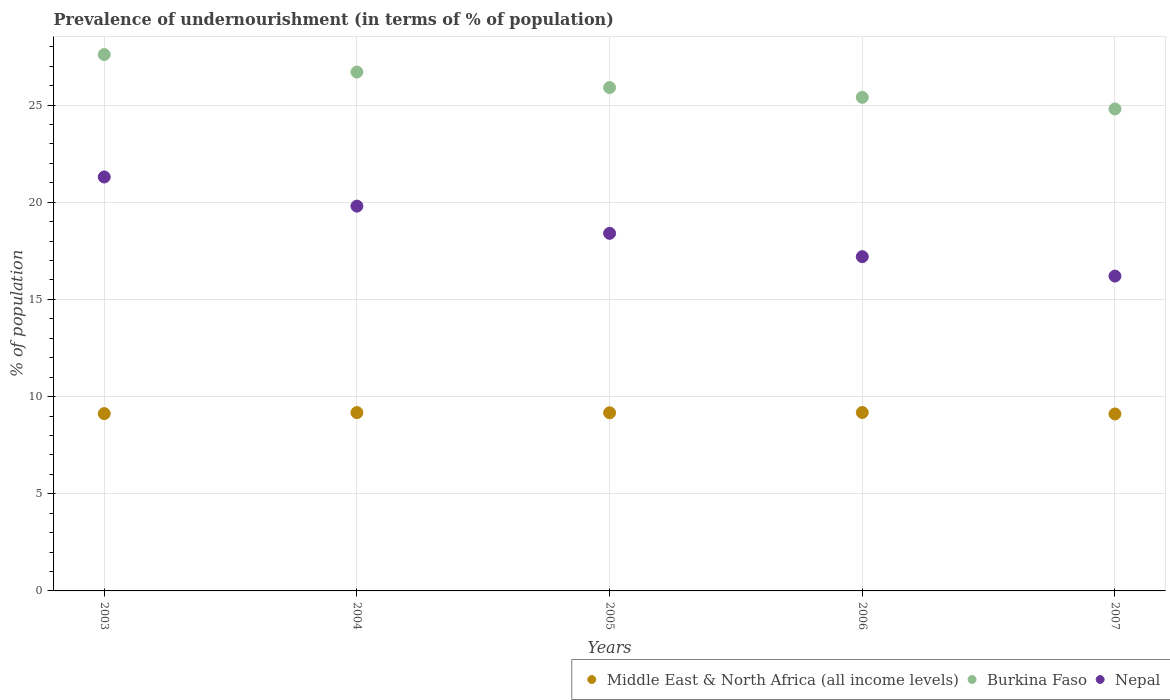How many different coloured dotlines are there?
Give a very brief answer. 3. Is the number of dotlines equal to the number of legend labels?
Your response must be concise. Yes. What is the percentage of undernourished population in Burkina Faso in 2003?
Provide a succinct answer. 27.6. Across all years, what is the maximum percentage of undernourished population in Nepal?
Give a very brief answer. 21.3. Across all years, what is the minimum percentage of undernourished population in Burkina Faso?
Provide a succinct answer. 24.8. What is the total percentage of undernourished population in Nepal in the graph?
Provide a short and direct response. 92.9. What is the difference between the percentage of undernourished population in Burkina Faso in 2003 and that in 2007?
Give a very brief answer. 2.8. What is the difference between the percentage of undernourished population in Middle East & North Africa (all income levels) in 2003 and the percentage of undernourished population in Nepal in 2007?
Keep it short and to the point. -7.08. What is the average percentage of undernourished population in Burkina Faso per year?
Provide a succinct answer. 26.08. In the year 2003, what is the difference between the percentage of undernourished population in Middle East & North Africa (all income levels) and percentage of undernourished population in Burkina Faso?
Make the answer very short. -18.48. What is the ratio of the percentage of undernourished population in Burkina Faso in 2004 to that in 2005?
Offer a terse response. 1.03. Is the difference between the percentage of undernourished population in Middle East & North Africa (all income levels) in 2003 and 2004 greater than the difference between the percentage of undernourished population in Burkina Faso in 2003 and 2004?
Make the answer very short. No. What is the difference between the highest and the second highest percentage of undernourished population in Burkina Faso?
Offer a very short reply. 0.9. What is the difference between the highest and the lowest percentage of undernourished population in Burkina Faso?
Make the answer very short. 2.8. In how many years, is the percentage of undernourished population in Burkina Faso greater than the average percentage of undernourished population in Burkina Faso taken over all years?
Ensure brevity in your answer.  2. Is the sum of the percentage of undernourished population in Middle East & North Africa (all income levels) in 2003 and 2004 greater than the maximum percentage of undernourished population in Burkina Faso across all years?
Offer a terse response. No. How many dotlines are there?
Keep it short and to the point. 3. What is the difference between two consecutive major ticks on the Y-axis?
Provide a short and direct response. 5. Are the values on the major ticks of Y-axis written in scientific E-notation?
Your answer should be very brief. No. How many legend labels are there?
Give a very brief answer. 3. How are the legend labels stacked?
Offer a terse response. Horizontal. What is the title of the graph?
Your answer should be compact. Prevalence of undernourishment (in terms of % of population). What is the label or title of the X-axis?
Provide a short and direct response. Years. What is the label or title of the Y-axis?
Keep it short and to the point. % of population. What is the % of population of Middle East & North Africa (all income levels) in 2003?
Offer a very short reply. 9.12. What is the % of population of Burkina Faso in 2003?
Ensure brevity in your answer.  27.6. What is the % of population in Nepal in 2003?
Give a very brief answer. 21.3. What is the % of population of Middle East & North Africa (all income levels) in 2004?
Offer a terse response. 9.18. What is the % of population in Burkina Faso in 2004?
Keep it short and to the point. 26.7. What is the % of population of Nepal in 2004?
Your response must be concise. 19.8. What is the % of population in Middle East & North Africa (all income levels) in 2005?
Give a very brief answer. 9.17. What is the % of population of Burkina Faso in 2005?
Ensure brevity in your answer.  25.9. What is the % of population in Nepal in 2005?
Make the answer very short. 18.4. What is the % of population in Middle East & North Africa (all income levels) in 2006?
Ensure brevity in your answer.  9.18. What is the % of population of Burkina Faso in 2006?
Ensure brevity in your answer.  25.4. What is the % of population of Nepal in 2006?
Your response must be concise. 17.2. What is the % of population in Middle East & North Africa (all income levels) in 2007?
Ensure brevity in your answer.  9.11. What is the % of population of Burkina Faso in 2007?
Ensure brevity in your answer.  24.8. What is the % of population of Nepal in 2007?
Keep it short and to the point. 16.2. Across all years, what is the maximum % of population of Middle East & North Africa (all income levels)?
Offer a terse response. 9.18. Across all years, what is the maximum % of population in Burkina Faso?
Make the answer very short. 27.6. Across all years, what is the maximum % of population in Nepal?
Offer a terse response. 21.3. Across all years, what is the minimum % of population in Middle East & North Africa (all income levels)?
Your response must be concise. 9.11. Across all years, what is the minimum % of population in Burkina Faso?
Provide a short and direct response. 24.8. What is the total % of population in Middle East & North Africa (all income levels) in the graph?
Make the answer very short. 45.75. What is the total % of population of Burkina Faso in the graph?
Your answer should be compact. 130.4. What is the total % of population of Nepal in the graph?
Offer a terse response. 92.9. What is the difference between the % of population in Middle East & North Africa (all income levels) in 2003 and that in 2004?
Your answer should be very brief. -0.05. What is the difference between the % of population of Burkina Faso in 2003 and that in 2004?
Keep it short and to the point. 0.9. What is the difference between the % of population of Middle East & North Africa (all income levels) in 2003 and that in 2005?
Offer a very short reply. -0.04. What is the difference between the % of population of Nepal in 2003 and that in 2005?
Ensure brevity in your answer.  2.9. What is the difference between the % of population in Middle East & North Africa (all income levels) in 2003 and that in 2006?
Your answer should be very brief. -0.06. What is the difference between the % of population in Middle East & North Africa (all income levels) in 2003 and that in 2007?
Your answer should be very brief. 0.02. What is the difference between the % of population of Nepal in 2003 and that in 2007?
Offer a terse response. 5.1. What is the difference between the % of population of Middle East & North Africa (all income levels) in 2004 and that in 2005?
Offer a very short reply. 0.01. What is the difference between the % of population of Burkina Faso in 2004 and that in 2005?
Ensure brevity in your answer.  0.8. What is the difference between the % of population of Nepal in 2004 and that in 2005?
Provide a succinct answer. 1.4. What is the difference between the % of population of Middle East & North Africa (all income levels) in 2004 and that in 2006?
Your answer should be very brief. -0. What is the difference between the % of population of Middle East & North Africa (all income levels) in 2004 and that in 2007?
Your response must be concise. 0.07. What is the difference between the % of population of Burkina Faso in 2004 and that in 2007?
Your response must be concise. 1.9. What is the difference between the % of population of Nepal in 2004 and that in 2007?
Give a very brief answer. 3.6. What is the difference between the % of population in Middle East & North Africa (all income levels) in 2005 and that in 2006?
Your answer should be compact. -0.01. What is the difference between the % of population in Burkina Faso in 2005 and that in 2006?
Ensure brevity in your answer.  0.5. What is the difference between the % of population in Middle East & North Africa (all income levels) in 2005 and that in 2007?
Provide a succinct answer. 0.06. What is the difference between the % of population of Middle East & North Africa (all income levels) in 2006 and that in 2007?
Offer a terse response. 0.08. What is the difference between the % of population of Middle East & North Africa (all income levels) in 2003 and the % of population of Burkina Faso in 2004?
Your answer should be very brief. -17.58. What is the difference between the % of population in Middle East & North Africa (all income levels) in 2003 and the % of population in Nepal in 2004?
Your answer should be compact. -10.68. What is the difference between the % of population of Middle East & North Africa (all income levels) in 2003 and the % of population of Burkina Faso in 2005?
Provide a short and direct response. -16.78. What is the difference between the % of population of Middle East & North Africa (all income levels) in 2003 and the % of population of Nepal in 2005?
Offer a terse response. -9.28. What is the difference between the % of population in Burkina Faso in 2003 and the % of population in Nepal in 2005?
Ensure brevity in your answer.  9.2. What is the difference between the % of population in Middle East & North Africa (all income levels) in 2003 and the % of population in Burkina Faso in 2006?
Make the answer very short. -16.28. What is the difference between the % of population of Middle East & North Africa (all income levels) in 2003 and the % of population of Nepal in 2006?
Keep it short and to the point. -8.08. What is the difference between the % of population of Burkina Faso in 2003 and the % of population of Nepal in 2006?
Your answer should be compact. 10.4. What is the difference between the % of population of Middle East & North Africa (all income levels) in 2003 and the % of population of Burkina Faso in 2007?
Keep it short and to the point. -15.68. What is the difference between the % of population of Middle East & North Africa (all income levels) in 2003 and the % of population of Nepal in 2007?
Offer a terse response. -7.08. What is the difference between the % of population of Burkina Faso in 2003 and the % of population of Nepal in 2007?
Offer a very short reply. 11.4. What is the difference between the % of population of Middle East & North Africa (all income levels) in 2004 and the % of population of Burkina Faso in 2005?
Provide a short and direct response. -16.72. What is the difference between the % of population in Middle East & North Africa (all income levels) in 2004 and the % of population in Nepal in 2005?
Your answer should be very brief. -9.22. What is the difference between the % of population in Middle East & North Africa (all income levels) in 2004 and the % of population in Burkina Faso in 2006?
Your response must be concise. -16.22. What is the difference between the % of population in Middle East & North Africa (all income levels) in 2004 and the % of population in Nepal in 2006?
Give a very brief answer. -8.02. What is the difference between the % of population of Middle East & North Africa (all income levels) in 2004 and the % of population of Burkina Faso in 2007?
Ensure brevity in your answer.  -15.62. What is the difference between the % of population of Middle East & North Africa (all income levels) in 2004 and the % of population of Nepal in 2007?
Give a very brief answer. -7.02. What is the difference between the % of population of Middle East & North Africa (all income levels) in 2005 and the % of population of Burkina Faso in 2006?
Give a very brief answer. -16.23. What is the difference between the % of population in Middle East & North Africa (all income levels) in 2005 and the % of population in Nepal in 2006?
Your response must be concise. -8.03. What is the difference between the % of population in Burkina Faso in 2005 and the % of population in Nepal in 2006?
Your answer should be very brief. 8.7. What is the difference between the % of population of Middle East & North Africa (all income levels) in 2005 and the % of population of Burkina Faso in 2007?
Offer a terse response. -15.63. What is the difference between the % of population in Middle East & North Africa (all income levels) in 2005 and the % of population in Nepal in 2007?
Give a very brief answer. -7.03. What is the difference between the % of population of Middle East & North Africa (all income levels) in 2006 and the % of population of Burkina Faso in 2007?
Keep it short and to the point. -15.62. What is the difference between the % of population in Middle East & North Africa (all income levels) in 2006 and the % of population in Nepal in 2007?
Your answer should be very brief. -7.02. What is the average % of population of Middle East & North Africa (all income levels) per year?
Provide a succinct answer. 9.15. What is the average % of population of Burkina Faso per year?
Offer a very short reply. 26.08. What is the average % of population in Nepal per year?
Keep it short and to the point. 18.58. In the year 2003, what is the difference between the % of population in Middle East & North Africa (all income levels) and % of population in Burkina Faso?
Provide a short and direct response. -18.48. In the year 2003, what is the difference between the % of population in Middle East & North Africa (all income levels) and % of population in Nepal?
Your answer should be very brief. -12.18. In the year 2003, what is the difference between the % of population of Burkina Faso and % of population of Nepal?
Provide a short and direct response. 6.3. In the year 2004, what is the difference between the % of population of Middle East & North Africa (all income levels) and % of population of Burkina Faso?
Ensure brevity in your answer.  -17.52. In the year 2004, what is the difference between the % of population in Middle East & North Africa (all income levels) and % of population in Nepal?
Offer a terse response. -10.62. In the year 2004, what is the difference between the % of population in Burkina Faso and % of population in Nepal?
Offer a terse response. 6.9. In the year 2005, what is the difference between the % of population of Middle East & North Africa (all income levels) and % of population of Burkina Faso?
Provide a succinct answer. -16.73. In the year 2005, what is the difference between the % of population of Middle East & North Africa (all income levels) and % of population of Nepal?
Your response must be concise. -9.23. In the year 2006, what is the difference between the % of population of Middle East & North Africa (all income levels) and % of population of Burkina Faso?
Your answer should be compact. -16.22. In the year 2006, what is the difference between the % of population of Middle East & North Africa (all income levels) and % of population of Nepal?
Give a very brief answer. -8.02. In the year 2007, what is the difference between the % of population of Middle East & North Africa (all income levels) and % of population of Burkina Faso?
Make the answer very short. -15.69. In the year 2007, what is the difference between the % of population of Middle East & North Africa (all income levels) and % of population of Nepal?
Ensure brevity in your answer.  -7.09. What is the ratio of the % of population of Middle East & North Africa (all income levels) in 2003 to that in 2004?
Provide a succinct answer. 0.99. What is the ratio of the % of population in Burkina Faso in 2003 to that in 2004?
Your answer should be compact. 1.03. What is the ratio of the % of population in Nepal in 2003 to that in 2004?
Provide a succinct answer. 1.08. What is the ratio of the % of population of Burkina Faso in 2003 to that in 2005?
Ensure brevity in your answer.  1.07. What is the ratio of the % of population in Nepal in 2003 to that in 2005?
Keep it short and to the point. 1.16. What is the ratio of the % of population in Middle East & North Africa (all income levels) in 2003 to that in 2006?
Make the answer very short. 0.99. What is the ratio of the % of population of Burkina Faso in 2003 to that in 2006?
Offer a very short reply. 1.09. What is the ratio of the % of population of Nepal in 2003 to that in 2006?
Provide a succinct answer. 1.24. What is the ratio of the % of population of Burkina Faso in 2003 to that in 2007?
Provide a short and direct response. 1.11. What is the ratio of the % of population in Nepal in 2003 to that in 2007?
Your response must be concise. 1.31. What is the ratio of the % of population in Burkina Faso in 2004 to that in 2005?
Your answer should be compact. 1.03. What is the ratio of the % of population in Nepal in 2004 to that in 2005?
Offer a very short reply. 1.08. What is the ratio of the % of population in Burkina Faso in 2004 to that in 2006?
Give a very brief answer. 1.05. What is the ratio of the % of population of Nepal in 2004 to that in 2006?
Your response must be concise. 1.15. What is the ratio of the % of population of Middle East & North Africa (all income levels) in 2004 to that in 2007?
Offer a terse response. 1.01. What is the ratio of the % of population in Burkina Faso in 2004 to that in 2007?
Ensure brevity in your answer.  1.08. What is the ratio of the % of population of Nepal in 2004 to that in 2007?
Your response must be concise. 1.22. What is the ratio of the % of population of Burkina Faso in 2005 to that in 2006?
Provide a short and direct response. 1.02. What is the ratio of the % of population in Nepal in 2005 to that in 2006?
Keep it short and to the point. 1.07. What is the ratio of the % of population in Middle East & North Africa (all income levels) in 2005 to that in 2007?
Your answer should be very brief. 1.01. What is the ratio of the % of population of Burkina Faso in 2005 to that in 2007?
Provide a succinct answer. 1.04. What is the ratio of the % of population in Nepal in 2005 to that in 2007?
Give a very brief answer. 1.14. What is the ratio of the % of population of Middle East & North Africa (all income levels) in 2006 to that in 2007?
Your answer should be compact. 1.01. What is the ratio of the % of population of Burkina Faso in 2006 to that in 2007?
Offer a very short reply. 1.02. What is the ratio of the % of population of Nepal in 2006 to that in 2007?
Offer a terse response. 1.06. What is the difference between the highest and the second highest % of population in Middle East & North Africa (all income levels)?
Keep it short and to the point. 0. What is the difference between the highest and the second highest % of population in Burkina Faso?
Provide a succinct answer. 0.9. What is the difference between the highest and the lowest % of population of Middle East & North Africa (all income levels)?
Your response must be concise. 0.08. What is the difference between the highest and the lowest % of population in Burkina Faso?
Ensure brevity in your answer.  2.8. What is the difference between the highest and the lowest % of population of Nepal?
Provide a short and direct response. 5.1. 